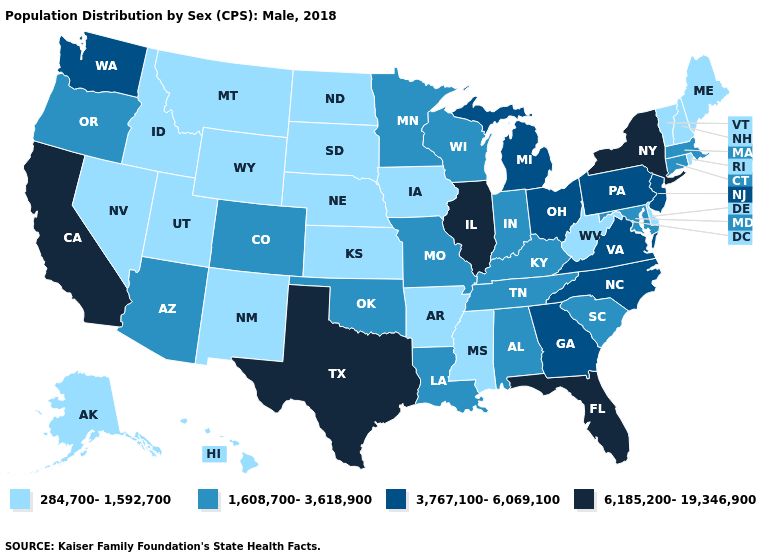Does the map have missing data?
Give a very brief answer. No. Name the states that have a value in the range 1,608,700-3,618,900?
Quick response, please. Alabama, Arizona, Colorado, Connecticut, Indiana, Kentucky, Louisiana, Maryland, Massachusetts, Minnesota, Missouri, Oklahoma, Oregon, South Carolina, Tennessee, Wisconsin. Among the states that border Illinois , which have the highest value?
Answer briefly. Indiana, Kentucky, Missouri, Wisconsin. What is the highest value in the USA?
Write a very short answer. 6,185,200-19,346,900. Name the states that have a value in the range 284,700-1,592,700?
Give a very brief answer. Alaska, Arkansas, Delaware, Hawaii, Idaho, Iowa, Kansas, Maine, Mississippi, Montana, Nebraska, Nevada, New Hampshire, New Mexico, North Dakota, Rhode Island, South Dakota, Utah, Vermont, West Virginia, Wyoming. What is the value of Michigan?
Short answer required. 3,767,100-6,069,100. What is the value of Washington?
Be succinct. 3,767,100-6,069,100. What is the value of New Mexico?
Answer briefly. 284,700-1,592,700. What is the value of Wyoming?
Concise answer only. 284,700-1,592,700. What is the value of Connecticut?
Be succinct. 1,608,700-3,618,900. Name the states that have a value in the range 3,767,100-6,069,100?
Write a very short answer. Georgia, Michigan, New Jersey, North Carolina, Ohio, Pennsylvania, Virginia, Washington. What is the value of Colorado?
Short answer required. 1,608,700-3,618,900. Does the first symbol in the legend represent the smallest category?
Keep it brief. Yes. Name the states that have a value in the range 3,767,100-6,069,100?
Short answer required. Georgia, Michigan, New Jersey, North Carolina, Ohio, Pennsylvania, Virginia, Washington. Does Washington have a higher value than Oklahoma?
Write a very short answer. Yes. 